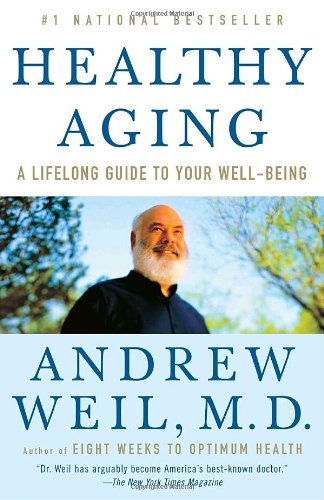Is this a fitness book? Yes, this book can be considered under the fitness umbrella as it includes numerous strategies and recommendations for maintaining physical health and wellness throughout the aging process. 